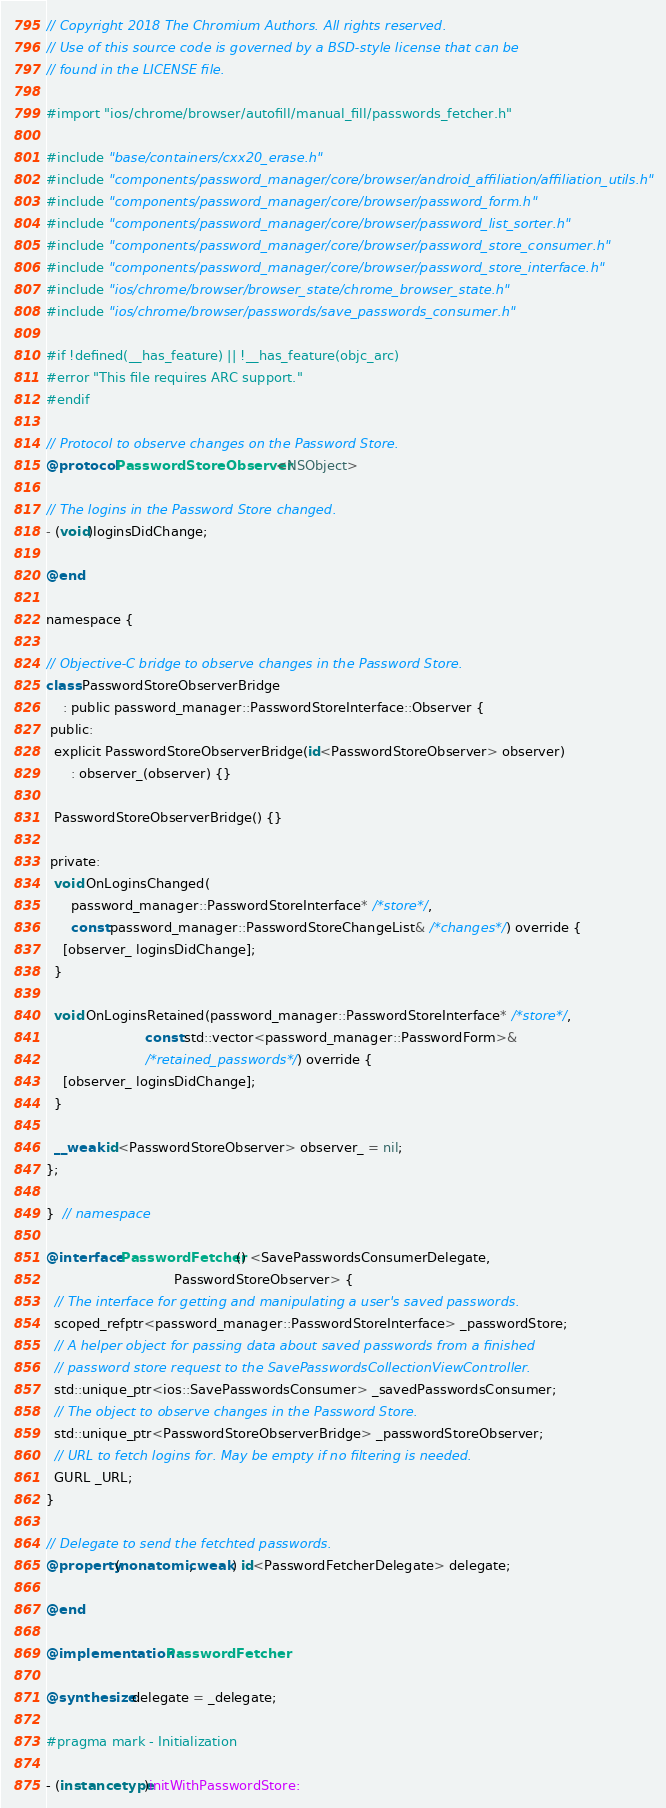Convert code to text. <code><loc_0><loc_0><loc_500><loc_500><_ObjectiveC_>// Copyright 2018 The Chromium Authors. All rights reserved.
// Use of this source code is governed by a BSD-style license that can be
// found in the LICENSE file.

#import "ios/chrome/browser/autofill/manual_fill/passwords_fetcher.h"

#include "base/containers/cxx20_erase.h"
#include "components/password_manager/core/browser/android_affiliation/affiliation_utils.h"
#include "components/password_manager/core/browser/password_form.h"
#include "components/password_manager/core/browser/password_list_sorter.h"
#include "components/password_manager/core/browser/password_store_consumer.h"
#include "components/password_manager/core/browser/password_store_interface.h"
#include "ios/chrome/browser/browser_state/chrome_browser_state.h"
#include "ios/chrome/browser/passwords/save_passwords_consumer.h"

#if !defined(__has_feature) || !__has_feature(objc_arc)
#error "This file requires ARC support."
#endif

// Protocol to observe changes on the Password Store.
@protocol PasswordStoreObserver <NSObject>

// The logins in the Password Store changed.
- (void)loginsDidChange;

@end

namespace {

// Objective-C bridge to observe changes in the Password Store.
class PasswordStoreObserverBridge
    : public password_manager::PasswordStoreInterface::Observer {
 public:
  explicit PasswordStoreObserverBridge(id<PasswordStoreObserver> observer)
      : observer_(observer) {}

  PasswordStoreObserverBridge() {}

 private:
  void OnLoginsChanged(
      password_manager::PasswordStoreInterface* /*store*/,
      const password_manager::PasswordStoreChangeList& /*changes*/) override {
    [observer_ loginsDidChange];
  }

  void OnLoginsRetained(password_manager::PasswordStoreInterface* /*store*/,
                        const std::vector<password_manager::PasswordForm>&
                        /*retained_passwords*/) override {
    [observer_ loginsDidChange];
  }

  __weak id<PasswordStoreObserver> observer_ = nil;
};

}  // namespace

@interface PasswordFetcher () <SavePasswordsConsumerDelegate,
                               PasswordStoreObserver> {
  // The interface for getting and manipulating a user's saved passwords.
  scoped_refptr<password_manager::PasswordStoreInterface> _passwordStore;
  // A helper object for passing data about saved passwords from a finished
  // password store request to the SavePasswordsCollectionViewController.
  std::unique_ptr<ios::SavePasswordsConsumer> _savedPasswordsConsumer;
  // The object to observe changes in the Password Store.
  std::unique_ptr<PasswordStoreObserverBridge> _passwordStoreObserver;
  // URL to fetch logins for. May be empty if no filtering is needed.
  GURL _URL;
}

// Delegate to send the fetchted passwords.
@property(nonatomic, weak) id<PasswordFetcherDelegate> delegate;

@end

@implementation PasswordFetcher

@synthesize delegate = _delegate;

#pragma mark - Initialization

- (instancetype)initWithPasswordStore:</code> 